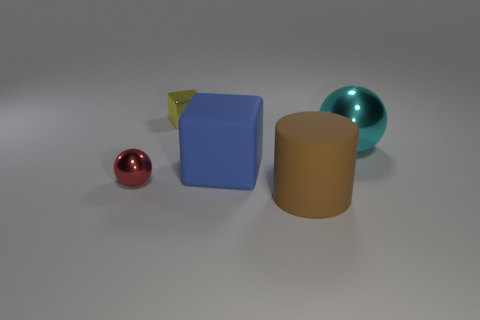Subtract all blue blocks. How many blocks are left? 1 Add 3 matte blocks. How many objects exist? 8 Subtract all balls. How many objects are left? 3 Subtract 1 cubes. How many cubes are left? 1 Subtract 1 brown cylinders. How many objects are left? 4 Subtract all purple blocks. Subtract all green cylinders. How many blocks are left? 2 Subtract all brown cylinders. How many red spheres are left? 1 Subtract all large rubber cubes. Subtract all small yellow metal objects. How many objects are left? 3 Add 4 cylinders. How many cylinders are left? 5 Add 1 large cylinders. How many large cylinders exist? 2 